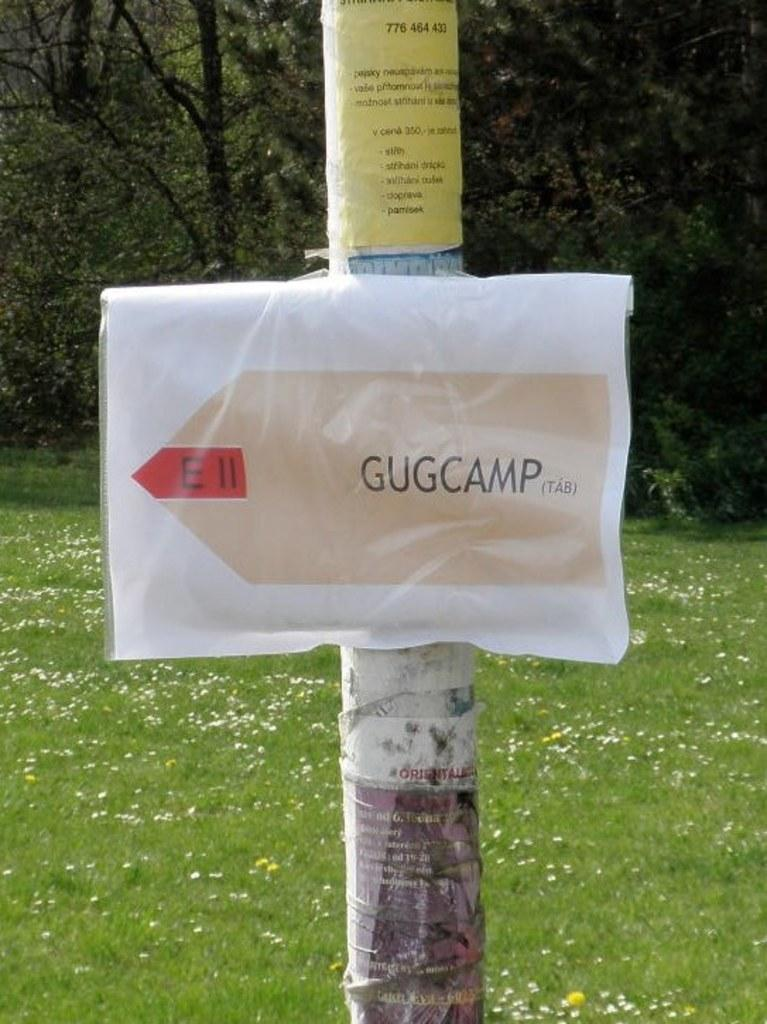What is featured on the pole in the image? There is a poster placed on a pole in the image. What can be seen in the background of the image? There are trees, plants, and grass in the background of the image. What type of orange twist can be seen in the sink in the image? There is no orange twist or sink present in the image. 